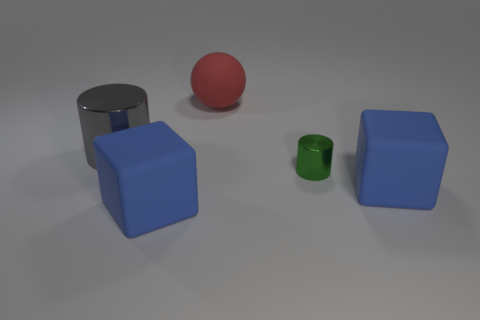Do the green thing and the red matte thing right of the gray object have the same shape? no 